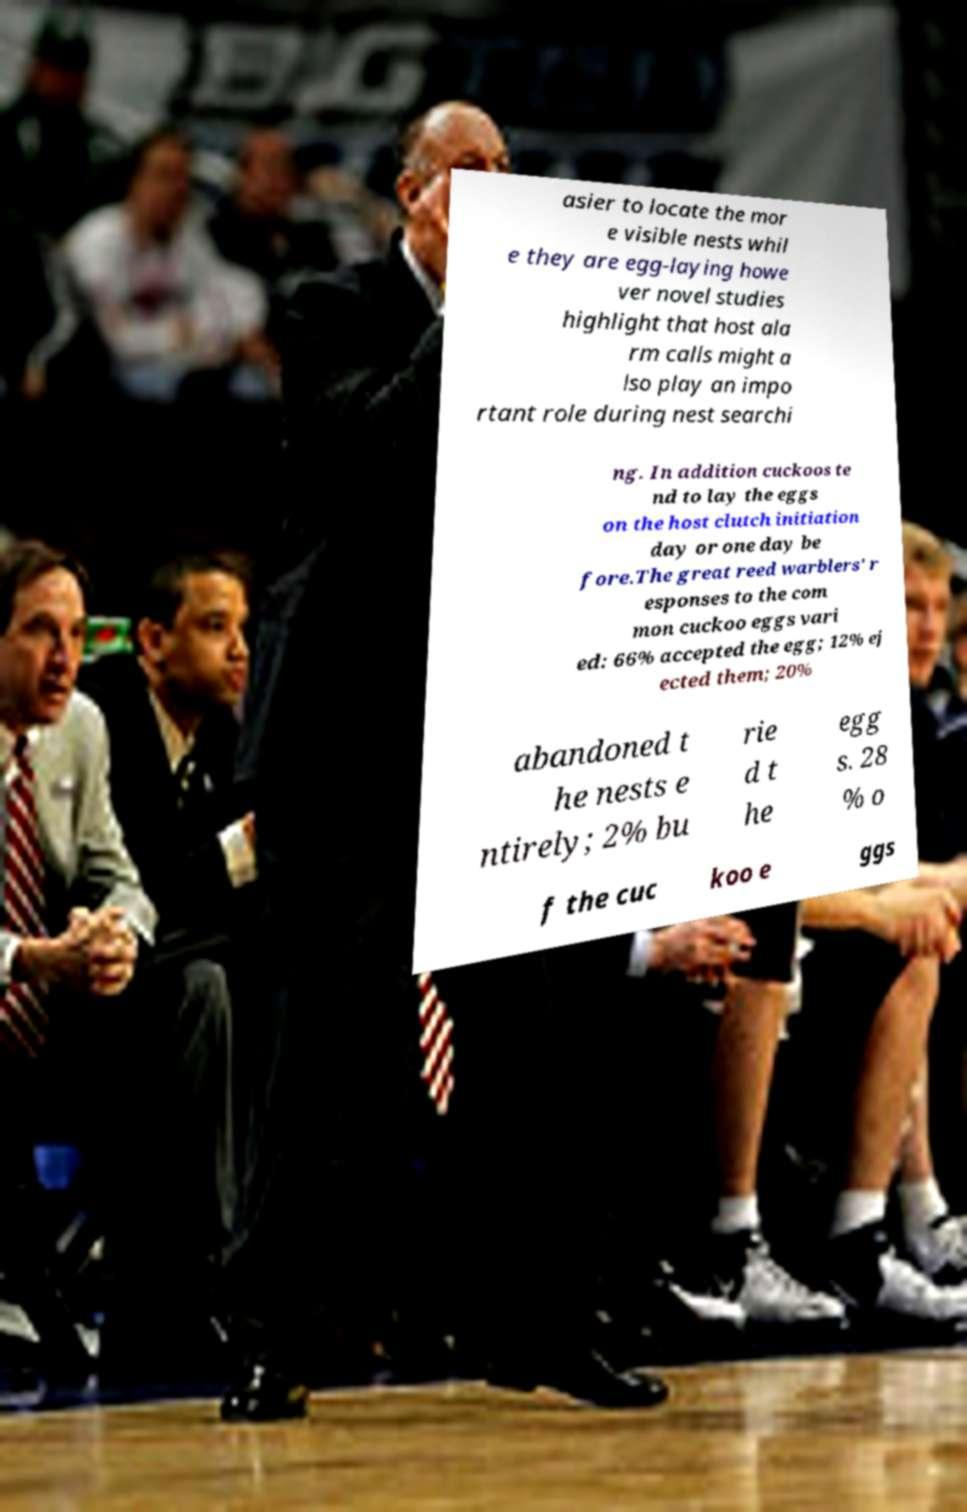There's text embedded in this image that I need extracted. Can you transcribe it verbatim? asier to locate the mor e visible nests whil e they are egg-laying howe ver novel studies highlight that host ala rm calls might a lso play an impo rtant role during nest searchi ng. In addition cuckoos te nd to lay the eggs on the host clutch initiation day or one day be fore.The great reed warblers' r esponses to the com mon cuckoo eggs vari ed: 66% accepted the egg; 12% ej ected them; 20% abandoned t he nests e ntirely; 2% bu rie d t he egg s. 28 % o f the cuc koo e ggs 